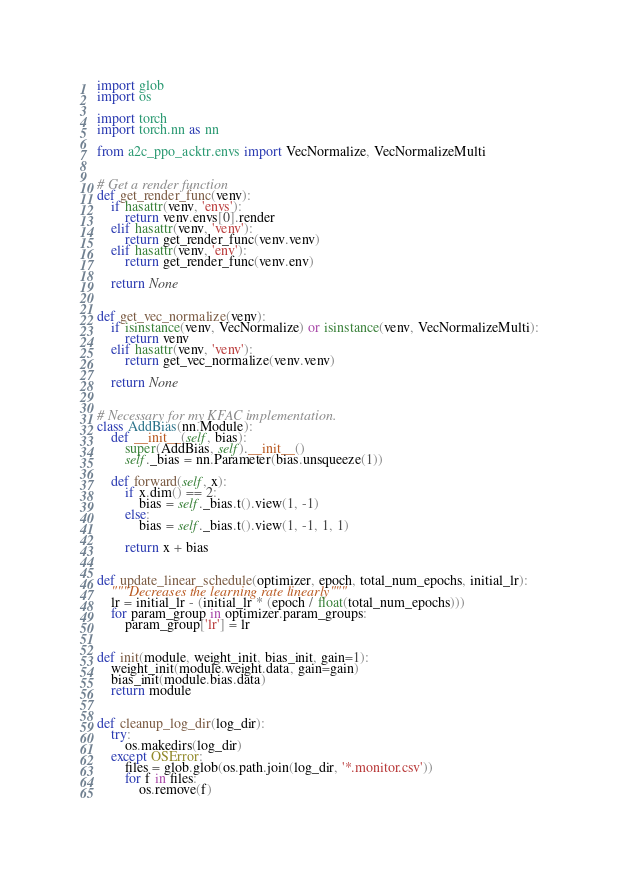Convert code to text. <code><loc_0><loc_0><loc_500><loc_500><_Python_>import glob
import os

import torch
import torch.nn as nn

from a2c_ppo_acktr.envs import VecNormalize, VecNormalizeMulti


# Get a render function
def get_render_func(venv):
    if hasattr(venv, 'envs'):
        return venv.envs[0].render
    elif hasattr(venv, 'venv'):
        return get_render_func(venv.venv)
    elif hasattr(venv, 'env'):
        return get_render_func(venv.env)

    return None


def get_vec_normalize(venv):
    if isinstance(venv, VecNormalize) or isinstance(venv, VecNormalizeMulti):
        return venv
    elif hasattr(venv, 'venv'):
        return get_vec_normalize(venv.venv)

    return None


# Necessary for my KFAC implementation.
class AddBias(nn.Module):
    def __init__(self, bias):
        super(AddBias, self).__init__()
        self._bias = nn.Parameter(bias.unsqueeze(1))

    def forward(self, x):
        if x.dim() == 2:
            bias = self._bias.t().view(1, -1)
        else:
            bias = self._bias.t().view(1, -1, 1, 1)

        return x + bias


def update_linear_schedule(optimizer, epoch, total_num_epochs, initial_lr):
    """Decreases the learning rate linearly"""
    lr = initial_lr - (initial_lr * (epoch / float(total_num_epochs)))
    for param_group in optimizer.param_groups:
        param_group['lr'] = lr


def init(module, weight_init, bias_init, gain=1):
    weight_init(module.weight.data, gain=gain)
    bias_init(module.bias.data)
    return module


def cleanup_log_dir(log_dir):
    try:
        os.makedirs(log_dir)
    except OSError:
        files = glob.glob(os.path.join(log_dir, '*.monitor.csv'))
        for f in files:
            os.remove(f)
</code> 